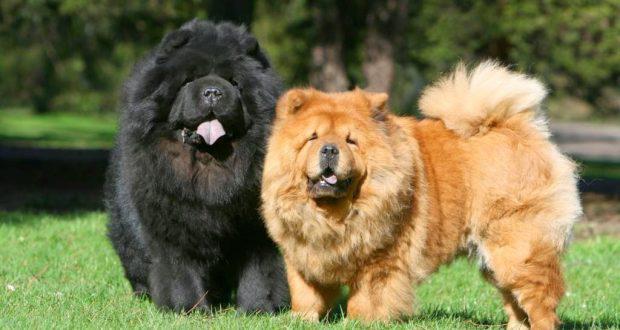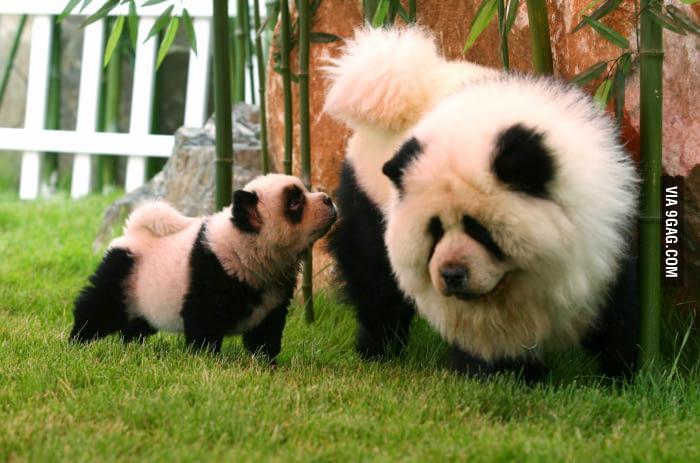The first image is the image on the left, the second image is the image on the right. Analyze the images presented: Is the assertion "There are just two dogs." valid? Answer yes or no. No. The first image is the image on the left, the second image is the image on the right. Assess this claim about the two images: "The left image contains exactly one red-orange chow puppy, and the right image contains exactly one red-orange adult chow.". Correct or not? Answer yes or no. No. 